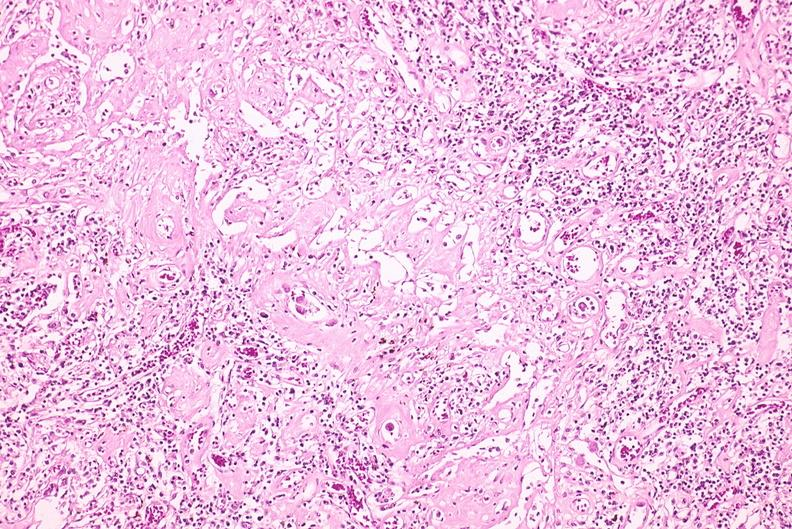does this image show lymph node, cytomegalovirus?
Answer the question using a single word or phrase. Yes 